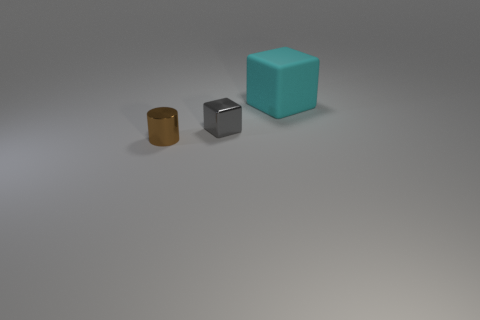Add 1 big cyan rubber blocks. How many objects exist? 4 Subtract all cubes. How many objects are left? 1 Add 3 tiny brown things. How many tiny brown things are left? 4 Add 1 cyan blocks. How many cyan blocks exist? 2 Subtract 0 blue balls. How many objects are left? 3 Subtract all large objects. Subtract all cyan things. How many objects are left? 1 